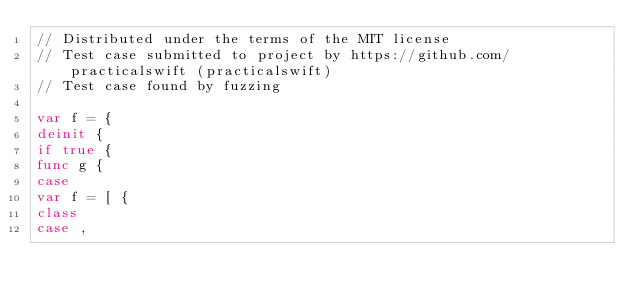<code> <loc_0><loc_0><loc_500><loc_500><_Swift_>// Distributed under the terms of the MIT license
// Test case submitted to project by https://github.com/practicalswift (practicalswift)
// Test case found by fuzzing

var f = {
deinit {
if true {
func g {
case
var f = [ {
class
case ,
</code> 